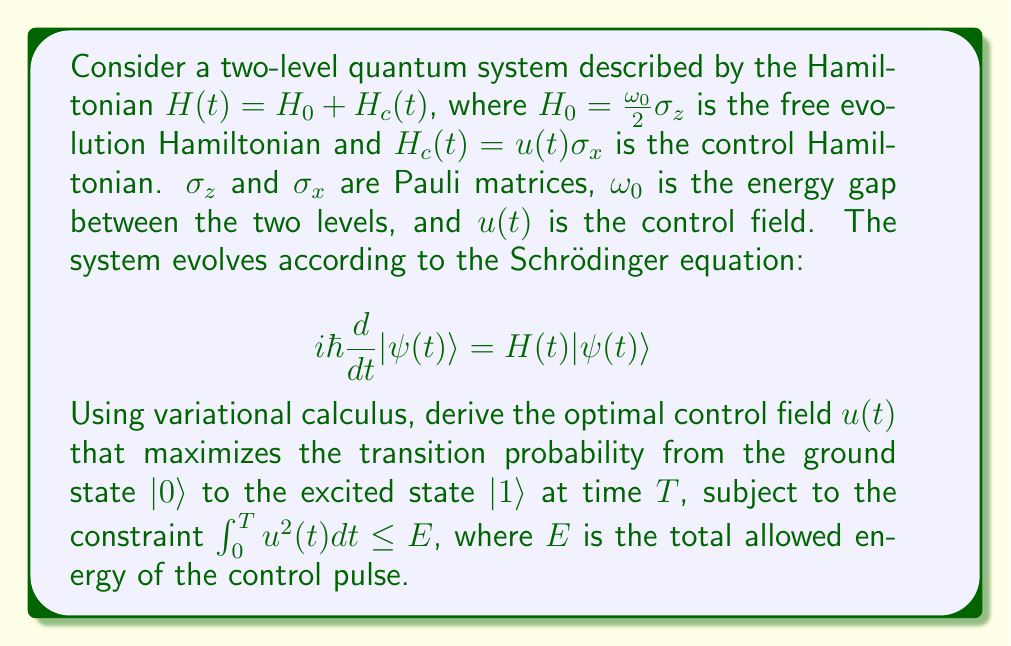Solve this math problem. To solve this problem, we'll use the principles of optimal control theory and variational calculus. Let's break it down step by step:

1) First, we define the cost functional to be maximized:

   $J[u] = |\langle 1|\psi(T)\rangle|^2$

   This represents the probability of finding the system in the excited state at time $T$.

2) We also have the constraint:

   $\int_0^T u^2(t)dt \leq E$

3) We can use the Pontryagin Maximum Principle to formulate the Hamiltonian for this optimal control problem:

   $\mathcal{H} = -\lambda u^2(t) + \text{Re}\{\langle p(t)|(-iH(t))|\psi(t)\rangle\}$

   where $\lambda$ is a Lagrange multiplier and $p(t)$ is the adjoint state.

4) The evolution equations for the state and adjoint state are:

   $i\hbar\frac{d}{dt}|\psi(t)\rangle = H(t)|\psi(t)\rangle$
   $i\hbar\frac{d}{dt}|p(t)\rangle = H(t)|p(t)\rangle$

5) The optimal control field satisfies:

   $\frac{\partial \mathcal{H}}{\partial u} = 0$

   This leads to:

   $u(t) = \frac{1}{2\lambda}\text{Im}\{\langle p(t)|\sigma_x|\psi(t)\rangle\}$

6) The boundary conditions are:

   $|\psi(0)\rangle = |0\rangle$
   $|p(T)\rangle = |1\rangle$

7) To solve this two-point boundary value problem, we can use numerical methods such as shooting or relaxation methods.

8) The value of $\lambda$ should be chosen to satisfy the energy constraint:

   $\int_0^T u^2(t)dt = E$

9) The optimal control field $u(t)$ will typically have a shape similar to a $\pi$-pulse, which in the ideal case would fully transfer the population from $|0\rangle$ to $|1\rangle$.

10) The maximum achievable transition probability will depend on the allowed energy $E$ and the total time $T$. In the limit of large $E$ or $T$, it should approach 1.
Answer: The optimal control field $u(t)$ is given by:

$$u(t) = \frac{1}{2\lambda}\text{Im}\{\langle p(t)|\sigma_x|\psi(t)\rangle\}$$

where $|\psi(t)\rangle$ and $|p(t)\rangle$ satisfy the Schrödinger equation and its adjoint with boundary conditions $|\psi(0)\rangle = |0\rangle$ and $|p(T)\rangle = |1\rangle$, respectively. The Lagrange multiplier $\lambda$ is chosen to satisfy the energy constraint $\int_0^T u^2(t)dt = E$. The exact form of $u(t)$ must be determined numerically due to the complexity of the coupled differential equations. 